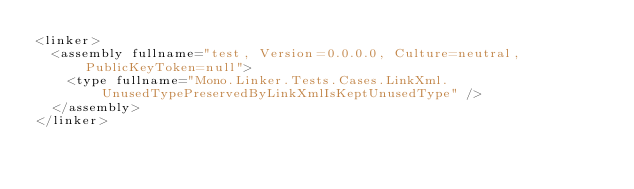<code> <loc_0><loc_0><loc_500><loc_500><_XML_><linker>
  <assembly fullname="test, Version=0.0.0.0, Culture=neutral, PublicKeyToken=null">
    <type fullname="Mono.Linker.Tests.Cases.LinkXml.UnusedTypePreservedByLinkXmlIsKeptUnusedType" />
  </assembly>
</linker></code> 